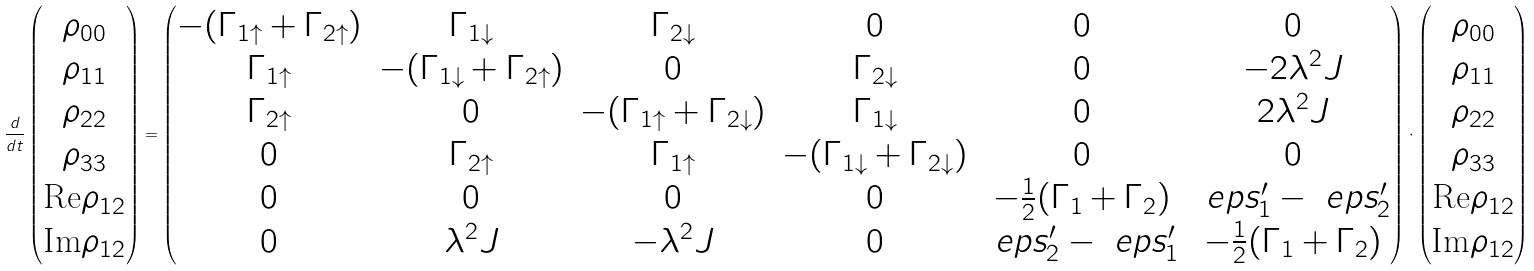Convert formula to latex. <formula><loc_0><loc_0><loc_500><loc_500>\frac { d } { d t } \begin{pmatrix} \rho _ { 0 0 } \\ \rho _ { 1 1 } \\ \rho _ { 2 2 } \\ \rho _ { 3 3 } \\ \text {Re} \rho _ { 1 2 } \\ \text {Im} \rho _ { 1 2 } \end{pmatrix} = \begin{pmatrix} - ( \Gamma _ { 1 \uparrow } + \Gamma _ { 2 \uparrow } ) & \Gamma _ { 1 \downarrow } & \Gamma _ { 2 \downarrow } & 0 & 0 & 0 \\ \Gamma _ { 1 \uparrow } & - ( \Gamma _ { 1 \downarrow } + \Gamma _ { 2 \uparrow } ) & 0 & \Gamma _ { 2 \downarrow } & 0 & - 2 \lambda ^ { 2 } J \\ \Gamma _ { 2 \uparrow } & 0 & - ( \Gamma _ { 1 \uparrow } + \Gamma _ { 2 \downarrow } ) & \Gamma _ { 1 \downarrow } & 0 & 2 \lambda ^ { 2 } J \\ 0 & \Gamma _ { 2 \uparrow } & \Gamma _ { 1 \uparrow } & - ( \Gamma _ { 1 \downarrow } + \Gamma _ { 2 \downarrow } ) & 0 & 0 \\ 0 & 0 & 0 & 0 & - \frac { 1 } { 2 } ( \Gamma _ { 1 } + \Gamma _ { 2 } ) & \ e p s _ { 1 } ^ { \prime } - \ e p s _ { 2 } ^ { \prime } \\ 0 & \lambda ^ { 2 } J & - \lambda ^ { 2 } J & 0 & \ e p s _ { 2 } ^ { \prime } - \ e p s _ { 1 } ^ { \prime } & - \frac { 1 } { 2 } ( \Gamma _ { 1 } + \Gamma _ { 2 } ) \end{pmatrix} \cdot \begin{pmatrix} \rho _ { 0 0 } \\ \rho _ { 1 1 } \\ \rho _ { 2 2 } \\ \rho _ { 3 3 } \\ \text {Re} \rho _ { 1 2 } \\ \text {Im} \rho _ { 1 2 } \end{pmatrix}</formula> 